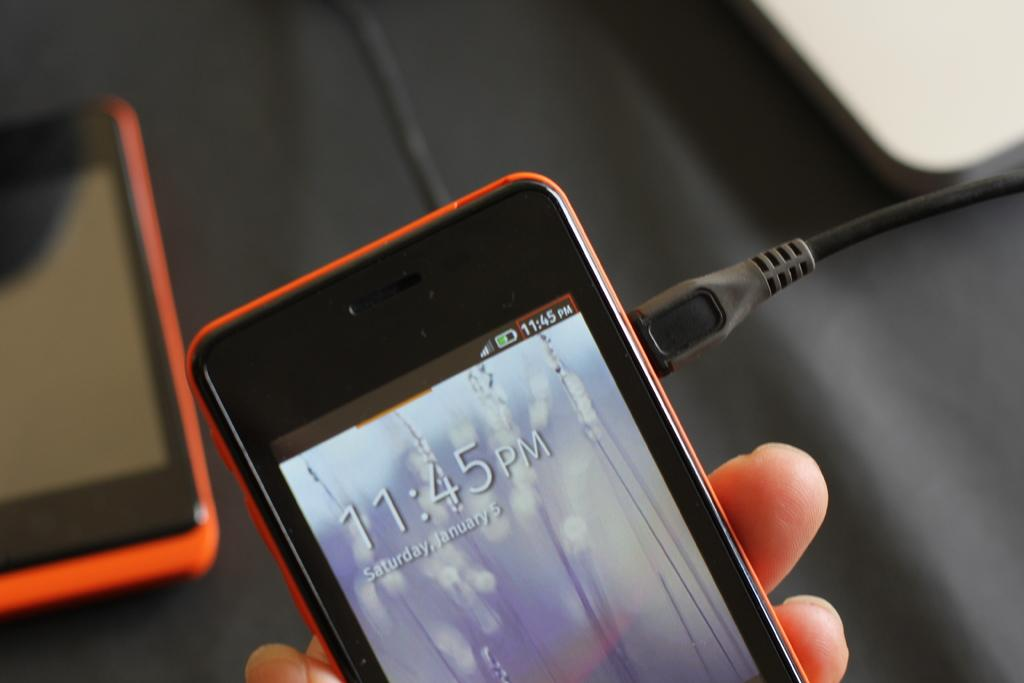<image>
Describe the image concisely. Fingers holding a cell phone with the display time of 11:45pm and Saturday January 5 under it. 